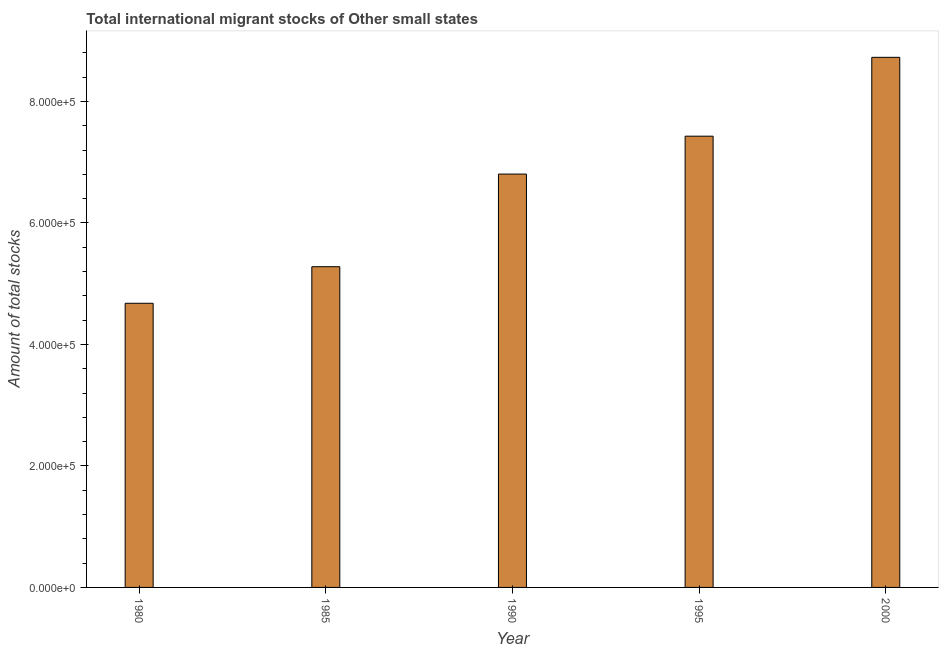What is the title of the graph?
Give a very brief answer. Total international migrant stocks of Other small states. What is the label or title of the Y-axis?
Keep it short and to the point. Amount of total stocks. What is the total number of international migrant stock in 1995?
Offer a very short reply. 7.43e+05. Across all years, what is the maximum total number of international migrant stock?
Give a very brief answer. 8.73e+05. Across all years, what is the minimum total number of international migrant stock?
Ensure brevity in your answer.  4.68e+05. In which year was the total number of international migrant stock maximum?
Your answer should be compact. 2000. What is the sum of the total number of international migrant stock?
Your answer should be very brief. 3.29e+06. What is the difference between the total number of international migrant stock in 1990 and 1995?
Give a very brief answer. -6.24e+04. What is the average total number of international migrant stock per year?
Ensure brevity in your answer.  6.58e+05. What is the median total number of international migrant stock?
Make the answer very short. 6.81e+05. In how many years, is the total number of international migrant stock greater than 560000 ?
Offer a terse response. 3. What is the ratio of the total number of international migrant stock in 1990 to that in 1995?
Keep it short and to the point. 0.92. Is the total number of international migrant stock in 1985 less than that in 2000?
Keep it short and to the point. Yes. Is the difference between the total number of international migrant stock in 1985 and 1995 greater than the difference between any two years?
Give a very brief answer. No. What is the difference between the highest and the second highest total number of international migrant stock?
Your answer should be very brief. 1.30e+05. What is the difference between the highest and the lowest total number of international migrant stock?
Your answer should be compact. 4.05e+05. How many years are there in the graph?
Ensure brevity in your answer.  5. What is the difference between two consecutive major ticks on the Y-axis?
Provide a short and direct response. 2.00e+05. Are the values on the major ticks of Y-axis written in scientific E-notation?
Give a very brief answer. Yes. What is the Amount of total stocks in 1980?
Your response must be concise. 4.68e+05. What is the Amount of total stocks of 1985?
Keep it short and to the point. 5.28e+05. What is the Amount of total stocks of 1990?
Keep it short and to the point. 6.81e+05. What is the Amount of total stocks of 1995?
Your answer should be very brief. 7.43e+05. What is the Amount of total stocks in 2000?
Offer a terse response. 8.73e+05. What is the difference between the Amount of total stocks in 1980 and 1985?
Your response must be concise. -6.02e+04. What is the difference between the Amount of total stocks in 1980 and 1990?
Give a very brief answer. -2.13e+05. What is the difference between the Amount of total stocks in 1980 and 1995?
Keep it short and to the point. -2.75e+05. What is the difference between the Amount of total stocks in 1980 and 2000?
Your answer should be compact. -4.05e+05. What is the difference between the Amount of total stocks in 1985 and 1990?
Keep it short and to the point. -1.53e+05. What is the difference between the Amount of total stocks in 1985 and 1995?
Your answer should be compact. -2.15e+05. What is the difference between the Amount of total stocks in 1985 and 2000?
Provide a short and direct response. -3.45e+05. What is the difference between the Amount of total stocks in 1990 and 1995?
Your response must be concise. -6.24e+04. What is the difference between the Amount of total stocks in 1990 and 2000?
Provide a short and direct response. -1.92e+05. What is the difference between the Amount of total stocks in 1995 and 2000?
Your answer should be compact. -1.30e+05. What is the ratio of the Amount of total stocks in 1980 to that in 1985?
Your response must be concise. 0.89. What is the ratio of the Amount of total stocks in 1980 to that in 1990?
Offer a terse response. 0.69. What is the ratio of the Amount of total stocks in 1980 to that in 1995?
Offer a terse response. 0.63. What is the ratio of the Amount of total stocks in 1980 to that in 2000?
Your answer should be very brief. 0.54. What is the ratio of the Amount of total stocks in 1985 to that in 1990?
Keep it short and to the point. 0.78. What is the ratio of the Amount of total stocks in 1985 to that in 1995?
Provide a succinct answer. 0.71. What is the ratio of the Amount of total stocks in 1985 to that in 2000?
Your response must be concise. 0.6. What is the ratio of the Amount of total stocks in 1990 to that in 1995?
Offer a terse response. 0.92. What is the ratio of the Amount of total stocks in 1990 to that in 2000?
Keep it short and to the point. 0.78. What is the ratio of the Amount of total stocks in 1995 to that in 2000?
Offer a very short reply. 0.85. 